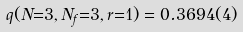Convert formula to latex. <formula><loc_0><loc_0><loc_500><loc_500>q ( N { = } 3 , N _ { f } { = } 3 , r { = } 1 ) = 0 . 3 6 9 4 ( 4 )</formula> 